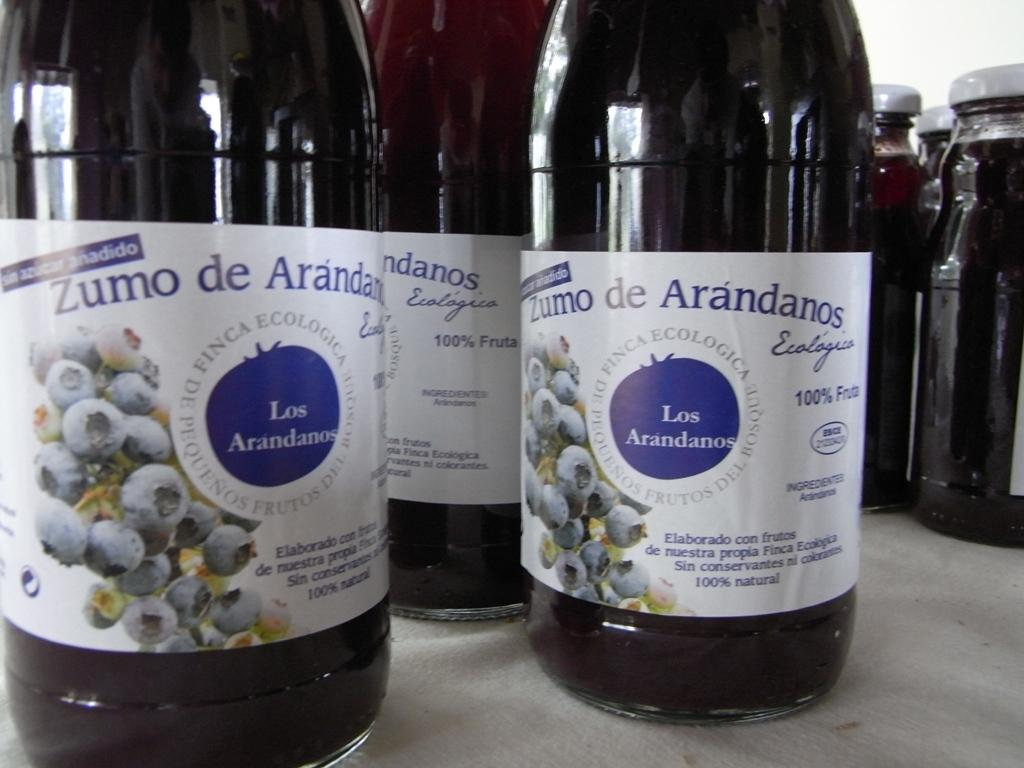What objects are present in the image? There are jars in the image. What is the surface on which the jars are placed? The jars are placed on a grey surface. How can we identify the contents of the jars? The jars are labelled. Are the jars closed or open? The jars are sealed. What can be seen in the background of the image? There is a white wall in the background of the image. How does the fog affect the visibility of the jars in the image? There is no fog present in the image, so it does not affect the visibility of the jars. 